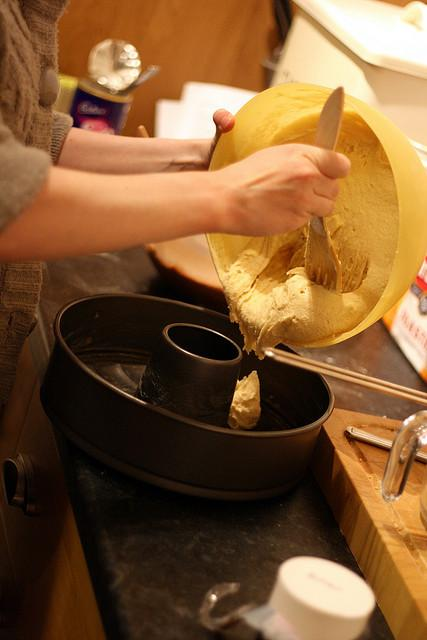What is being poured here? Please explain your reasoning. cake batter. It is going into a bundt pan to be baked for dessert. 